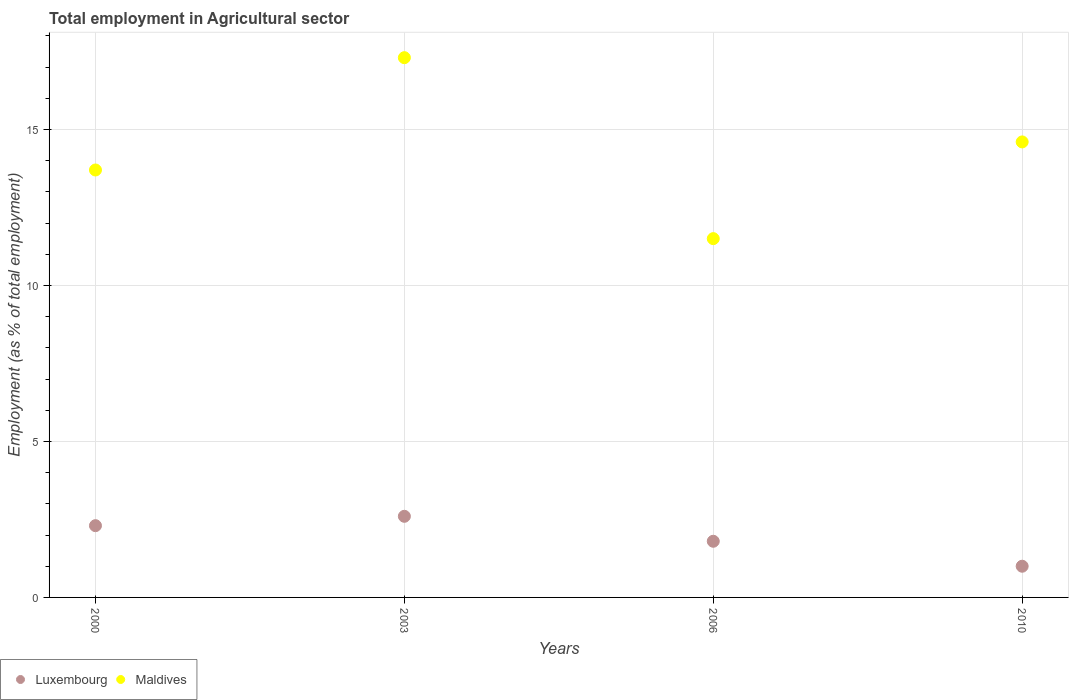Is the number of dotlines equal to the number of legend labels?
Keep it short and to the point. Yes. Across all years, what is the maximum employment in agricultural sector in Luxembourg?
Provide a succinct answer. 2.6. In which year was the employment in agricultural sector in Maldives minimum?
Provide a short and direct response. 2006. What is the total employment in agricultural sector in Maldives in the graph?
Your response must be concise. 57.1. What is the difference between the employment in agricultural sector in Maldives in 2000 and that in 2010?
Make the answer very short. -0.9. What is the difference between the employment in agricultural sector in Maldives in 2003 and the employment in agricultural sector in Luxembourg in 2000?
Your response must be concise. 15. What is the average employment in agricultural sector in Luxembourg per year?
Keep it short and to the point. 1.92. In the year 2010, what is the difference between the employment in agricultural sector in Maldives and employment in agricultural sector in Luxembourg?
Your response must be concise. 13.6. What is the ratio of the employment in agricultural sector in Luxembourg in 2000 to that in 2006?
Make the answer very short. 1.28. Is the difference between the employment in agricultural sector in Maldives in 2006 and 2010 greater than the difference between the employment in agricultural sector in Luxembourg in 2006 and 2010?
Your response must be concise. No. What is the difference between the highest and the second highest employment in agricultural sector in Maldives?
Provide a short and direct response. 2.7. What is the difference between the highest and the lowest employment in agricultural sector in Luxembourg?
Offer a very short reply. 1.6. In how many years, is the employment in agricultural sector in Luxembourg greater than the average employment in agricultural sector in Luxembourg taken over all years?
Offer a terse response. 2. Is the sum of the employment in agricultural sector in Luxembourg in 2000 and 2010 greater than the maximum employment in agricultural sector in Maldives across all years?
Offer a very short reply. No. Does the employment in agricultural sector in Maldives monotonically increase over the years?
Keep it short and to the point. No. Is the employment in agricultural sector in Luxembourg strictly greater than the employment in agricultural sector in Maldives over the years?
Your response must be concise. No. How many years are there in the graph?
Make the answer very short. 4. What is the difference between two consecutive major ticks on the Y-axis?
Keep it short and to the point. 5. Does the graph contain grids?
Offer a very short reply. Yes. What is the title of the graph?
Give a very brief answer. Total employment in Agricultural sector. Does "Nicaragua" appear as one of the legend labels in the graph?
Keep it short and to the point. No. What is the label or title of the Y-axis?
Your answer should be compact. Employment (as % of total employment). What is the Employment (as % of total employment) of Luxembourg in 2000?
Offer a terse response. 2.3. What is the Employment (as % of total employment) of Maldives in 2000?
Your answer should be very brief. 13.7. What is the Employment (as % of total employment) in Luxembourg in 2003?
Provide a short and direct response. 2.6. What is the Employment (as % of total employment) in Maldives in 2003?
Give a very brief answer. 17.3. What is the Employment (as % of total employment) in Luxembourg in 2006?
Offer a very short reply. 1.8. What is the Employment (as % of total employment) of Maldives in 2006?
Your answer should be compact. 11.5. What is the Employment (as % of total employment) of Luxembourg in 2010?
Offer a very short reply. 1. What is the Employment (as % of total employment) of Maldives in 2010?
Offer a very short reply. 14.6. Across all years, what is the maximum Employment (as % of total employment) of Luxembourg?
Offer a very short reply. 2.6. Across all years, what is the maximum Employment (as % of total employment) of Maldives?
Give a very brief answer. 17.3. What is the total Employment (as % of total employment) of Luxembourg in the graph?
Your answer should be compact. 7.7. What is the total Employment (as % of total employment) of Maldives in the graph?
Ensure brevity in your answer.  57.1. What is the difference between the Employment (as % of total employment) in Luxembourg in 2000 and that in 2003?
Provide a short and direct response. -0.3. What is the difference between the Employment (as % of total employment) in Maldives in 2000 and that in 2003?
Provide a short and direct response. -3.6. What is the difference between the Employment (as % of total employment) in Luxembourg in 2000 and that in 2010?
Your answer should be compact. 1.3. What is the difference between the Employment (as % of total employment) in Luxembourg in 2003 and that in 2006?
Your answer should be compact. 0.8. What is the difference between the Employment (as % of total employment) in Maldives in 2003 and that in 2006?
Make the answer very short. 5.8. What is the difference between the Employment (as % of total employment) of Luxembourg in 2003 and that in 2010?
Your answer should be very brief. 1.6. What is the difference between the Employment (as % of total employment) of Luxembourg in 2000 and the Employment (as % of total employment) of Maldives in 2003?
Your response must be concise. -15. What is the average Employment (as % of total employment) of Luxembourg per year?
Offer a very short reply. 1.93. What is the average Employment (as % of total employment) of Maldives per year?
Your answer should be compact. 14.28. In the year 2000, what is the difference between the Employment (as % of total employment) in Luxembourg and Employment (as % of total employment) in Maldives?
Provide a succinct answer. -11.4. In the year 2003, what is the difference between the Employment (as % of total employment) of Luxembourg and Employment (as % of total employment) of Maldives?
Your response must be concise. -14.7. In the year 2006, what is the difference between the Employment (as % of total employment) of Luxembourg and Employment (as % of total employment) of Maldives?
Your answer should be compact. -9.7. What is the ratio of the Employment (as % of total employment) in Luxembourg in 2000 to that in 2003?
Your answer should be very brief. 0.88. What is the ratio of the Employment (as % of total employment) in Maldives in 2000 to that in 2003?
Keep it short and to the point. 0.79. What is the ratio of the Employment (as % of total employment) in Luxembourg in 2000 to that in 2006?
Make the answer very short. 1.28. What is the ratio of the Employment (as % of total employment) in Maldives in 2000 to that in 2006?
Offer a very short reply. 1.19. What is the ratio of the Employment (as % of total employment) of Luxembourg in 2000 to that in 2010?
Your answer should be very brief. 2.3. What is the ratio of the Employment (as % of total employment) in Maldives in 2000 to that in 2010?
Offer a very short reply. 0.94. What is the ratio of the Employment (as % of total employment) in Luxembourg in 2003 to that in 2006?
Ensure brevity in your answer.  1.44. What is the ratio of the Employment (as % of total employment) in Maldives in 2003 to that in 2006?
Provide a succinct answer. 1.5. What is the ratio of the Employment (as % of total employment) of Luxembourg in 2003 to that in 2010?
Offer a very short reply. 2.6. What is the ratio of the Employment (as % of total employment) in Maldives in 2003 to that in 2010?
Offer a terse response. 1.18. What is the ratio of the Employment (as % of total employment) of Maldives in 2006 to that in 2010?
Make the answer very short. 0.79. What is the difference between the highest and the second highest Employment (as % of total employment) of Luxembourg?
Ensure brevity in your answer.  0.3. What is the difference between the highest and the second highest Employment (as % of total employment) in Maldives?
Your answer should be very brief. 2.7. What is the difference between the highest and the lowest Employment (as % of total employment) in Maldives?
Provide a short and direct response. 5.8. 